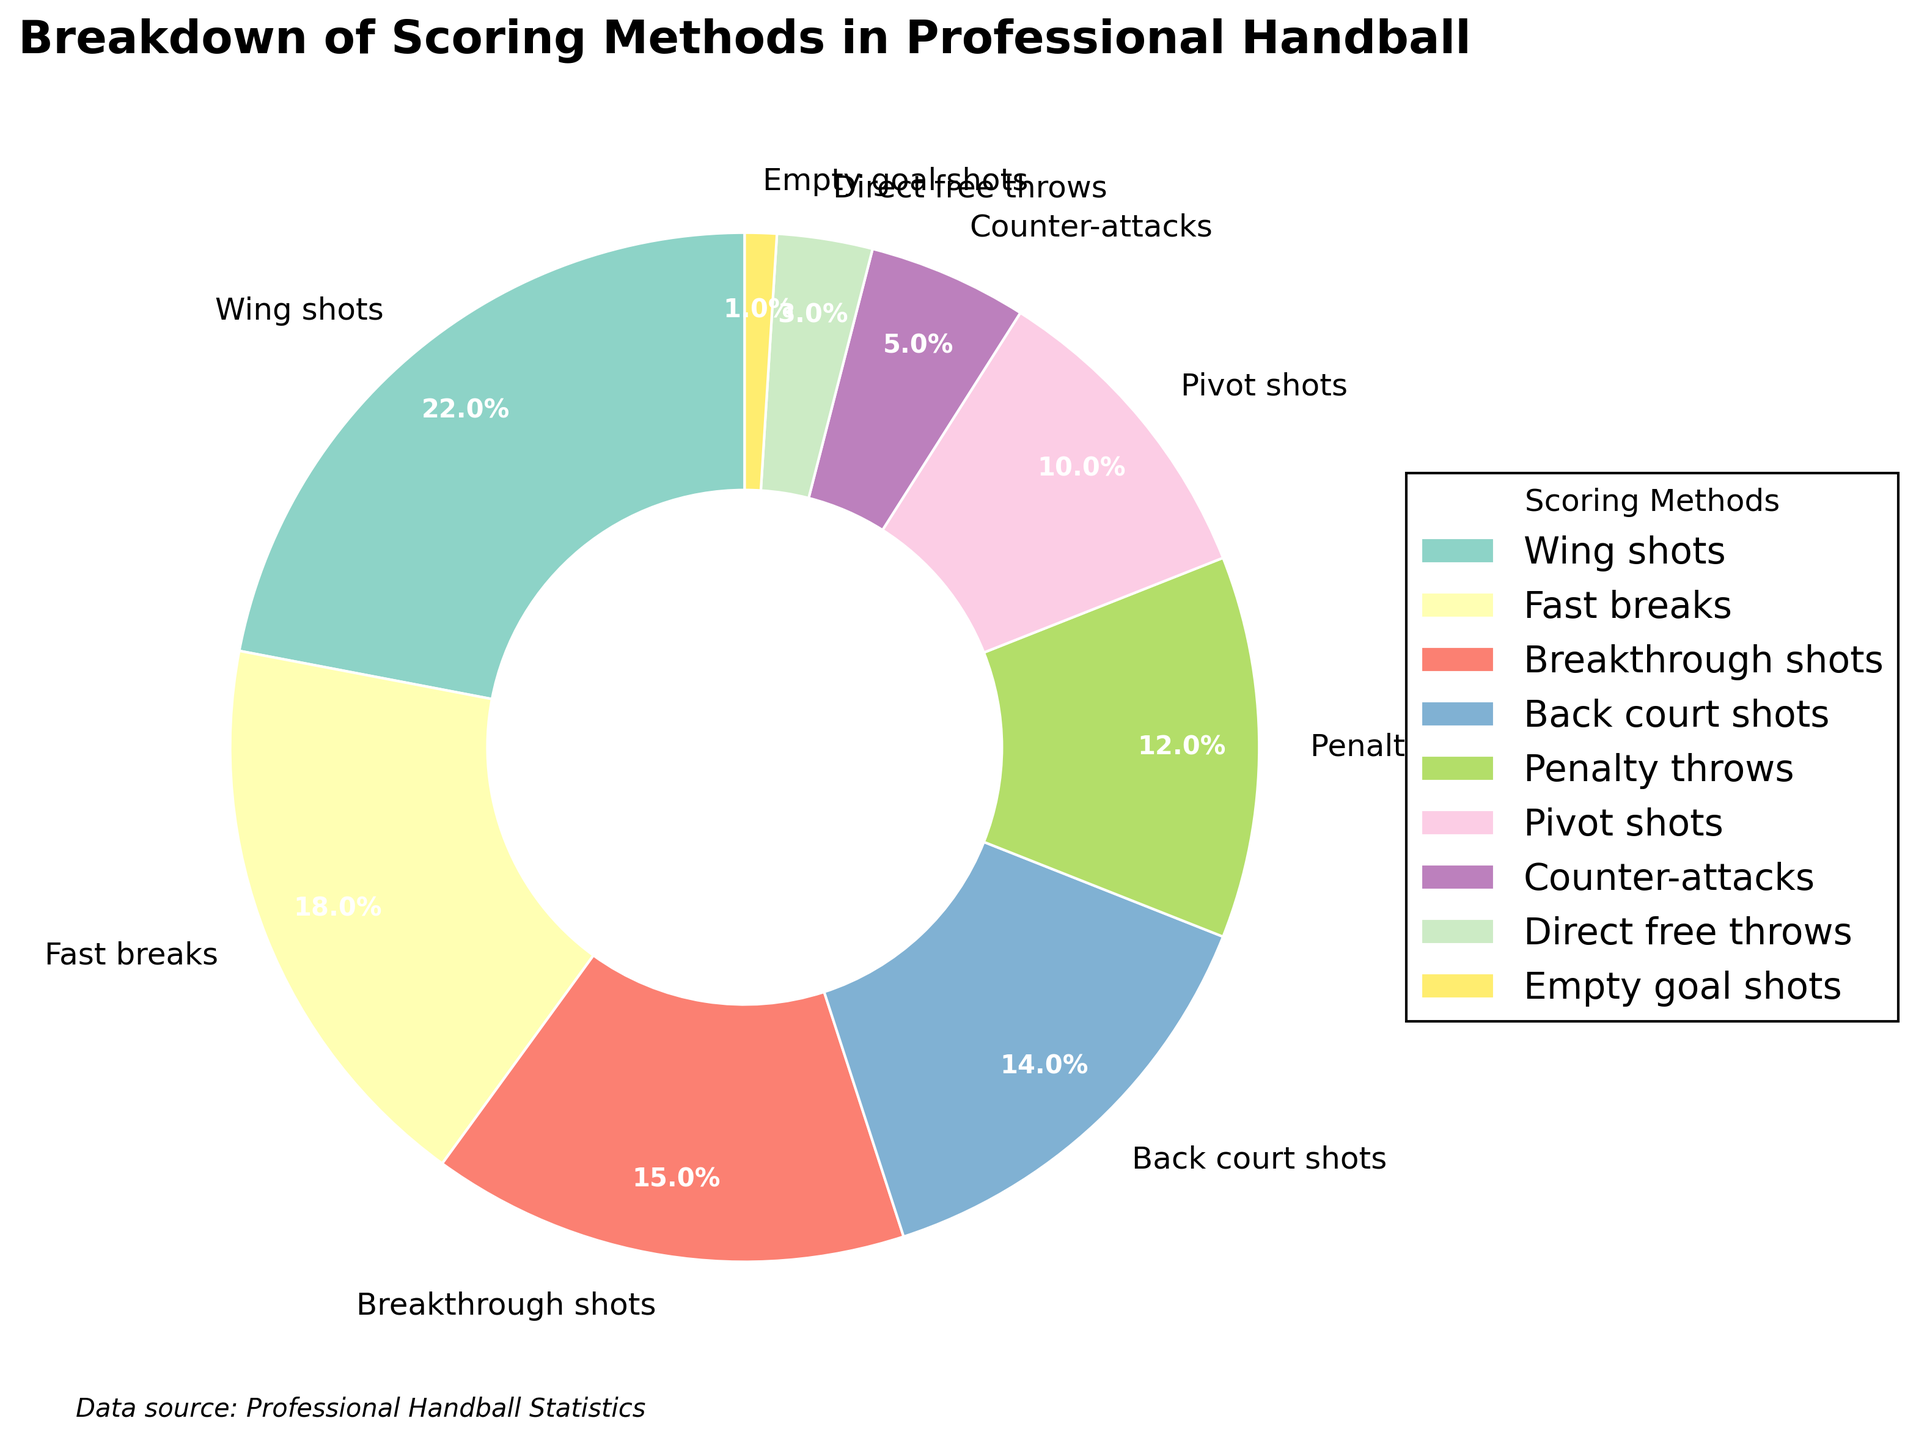Which scoring method accounts for the highest percentage? By looking at the legend and the pie chart, the "Wing shots" category occupies the largest section.
Answer: Wing shots How many scoring methods have a percentage greater than 15%? The categories listed as greater than 15% are "Wing shots" (22%) and "Fast breaks" (18%).
Answer: 2 What's the combined percentage of Back court shots and Pivot shots? The percentages of Back court shots and Pivot shots are 14% and 10% respectively. Adding them together, 14% + 10% = 24%.
Answer: 24% Is the percentage of Penalty throws greater than or less than Counter-attacks? Penalty throws account for 12%, while Counter-attacks account for 5%. Therefore, Penalty throws have a greater percentage.
Answer: Greater than Which scoring method has the smallest percentage? The smallest section of the pie chart corresponds to "Empty goal shots" at 1%.
Answer: Empty goal shots What is the difference in percentage between Wing shots and Breakthrough shots? Wing shots have 22% and Breakthrough shots have 15%. The difference is 22% - 15% = 7%.
Answer: 7% Are Back court shots and Fast breaks combined more or less than Wing shots? Summing the percentages of Back court shots (14%) and Fast breaks (18%) gives us 14% + 18% = 32%, which is greater than Wing shots at 22%.
Answer: More Which color represents the Penalty throws category in the pie chart? Observing the pie chart, Penalty throws are represented by a specific color section in the chart; refer to the corresponding text color in the legend to identify it.
Answer: Legend color What is the combined percentage of all methods under 10%? Categories with under 10% are "Pivot shots" (10%), "Counter-attacks" (5%), "Direct free throws" (3%), and "Empty goal shots" (1%). Adding these: 10% + 5% + 3% + 1% = 19%.
Answer: 19% Compare Pivot shots and Penalty throws; which one has a higher percentage? Penalty throws have 12% while Pivot shots have 10%. Therefore, Penalty throws have a higher percentage.
Answer: Penalty throws 